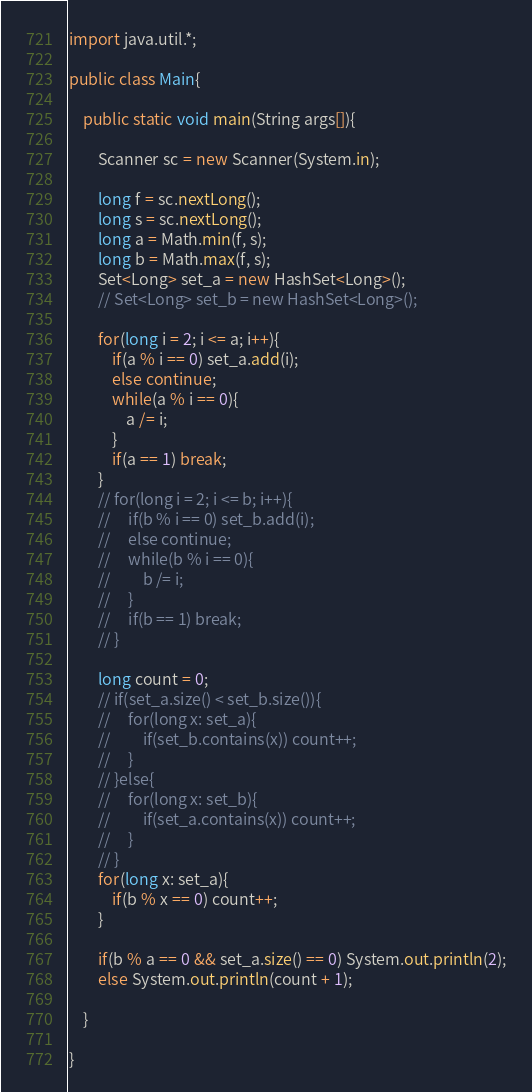Convert code to text. <code><loc_0><loc_0><loc_500><loc_500><_Java_>import java.util.*;

public class Main{

    public static void main(String args[]){

        Scanner sc = new Scanner(System.in);

		long f = sc.nextLong();
		long s = sc.nextLong();
        long a = Math.min(f, s);
        long b = Math.max(f, s);
        Set<Long> set_a = new HashSet<Long>();
        // Set<Long> set_b = new HashSet<Long>();

        for(long i = 2; i <= a; i++){
            if(a % i == 0) set_a.add(i);
            else continue;
            while(a % i == 0){
                a /= i;
            }
            if(a == 1) break;
        }
        // for(long i = 2; i <= b; i++){
        //     if(b % i == 0) set_b.add(i);
        //     else continue;
        //     while(b % i == 0){
        //         b /= i;
        //     }
        //     if(b == 1) break;
        // }

        long count = 0;
        // if(set_a.size() < set_b.size()){
        //     for(long x: set_a){
        //         if(set_b.contains(x)) count++;
        //     }
        // }else{
        //     for(long x: set_b){
        //         if(set_a.contains(x)) count++;
        //     }
        // }
        for(long x: set_a){
            if(b % x == 0) count++;
        }

        if(b % a == 0 && set_a.size() == 0) System.out.println(2);
        else System.out.println(count + 1);

    }

}
</code> 